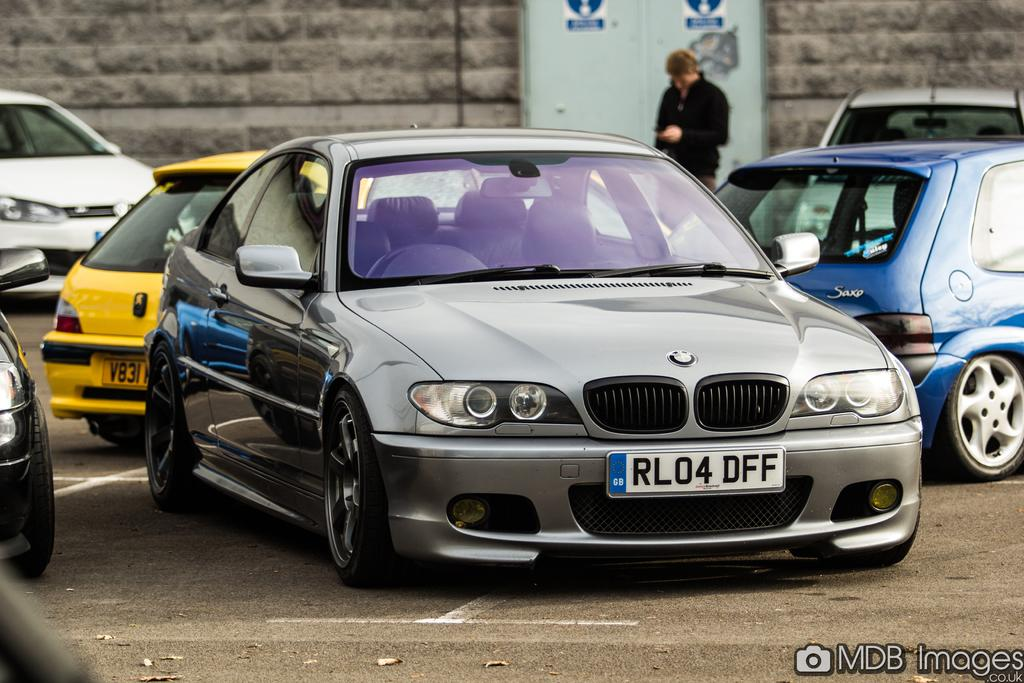<image>
Share a concise interpretation of the image provided. A BMW car with the license plate number RL04 DFF. 